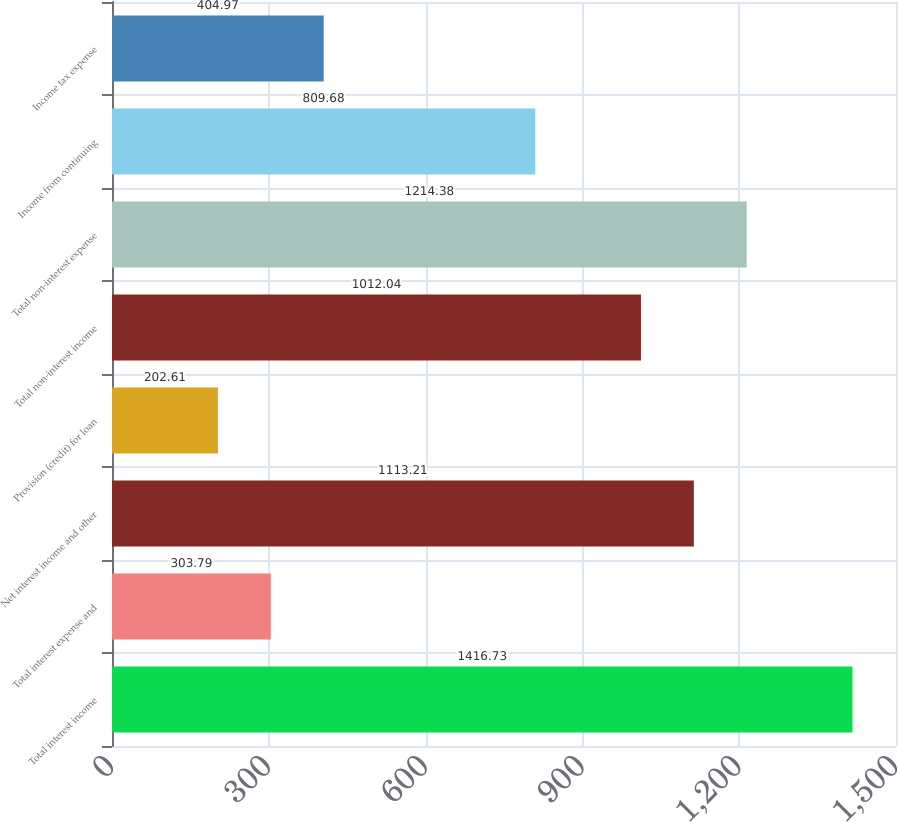<chart> <loc_0><loc_0><loc_500><loc_500><bar_chart><fcel>Total interest income<fcel>Total interest expense and<fcel>Net interest income and other<fcel>Provision (credit) for loan<fcel>Total non-interest income<fcel>Total non-interest expense<fcel>Income from continuing<fcel>Income tax expense<nl><fcel>1416.73<fcel>303.79<fcel>1113.21<fcel>202.61<fcel>1012.04<fcel>1214.38<fcel>809.68<fcel>404.97<nl></chart> 